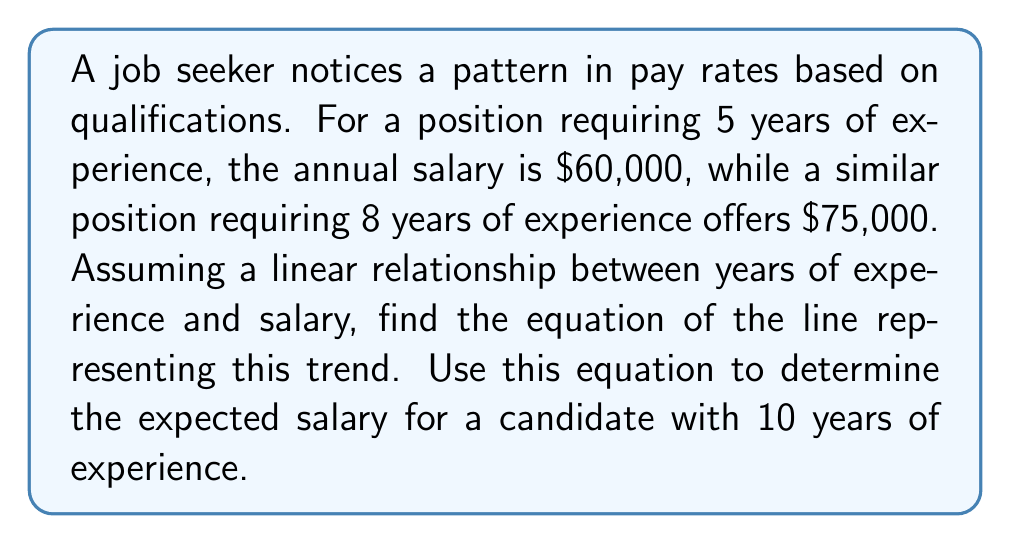Could you help me with this problem? Let's approach this step-by-step:

1) We have two points:
   $(5, 60000)$ and $(8, 75000)$

2) To find the equation of a line, we'll use the point-slope form:
   $y - y_1 = m(x - x_1)$

3) First, we need to calculate the slope $(m)$:
   $m = \frac{y_2 - y_1}{x_2 - x_1} = \frac{75000 - 60000}{8 - 5} = \frac{15000}{3} = 5000$

4) Now we can use either point to form the equation. Let's use $(5, 60000)$:
   $y - 60000 = 5000(x - 5)$

5) Simplify:
   $y = 5000(x - 5) + 60000$
   $y = 5000x - 25000 + 60000$
   $y = 5000x + 35000$

6) This is our final equation: $y = 5000x + 35000$, where $x$ is years of experience and $y$ is salary.

7) To find the expected salary for 10 years of experience, substitute $x = 10$:
   $y = 5000(10) + 35000 = 50000 + 35000 = 85000$

Therefore, the expected salary for a candidate with 10 years of experience is $85,000.
Answer: $y = 5000x + 35000$; $85,000 for 10 years 